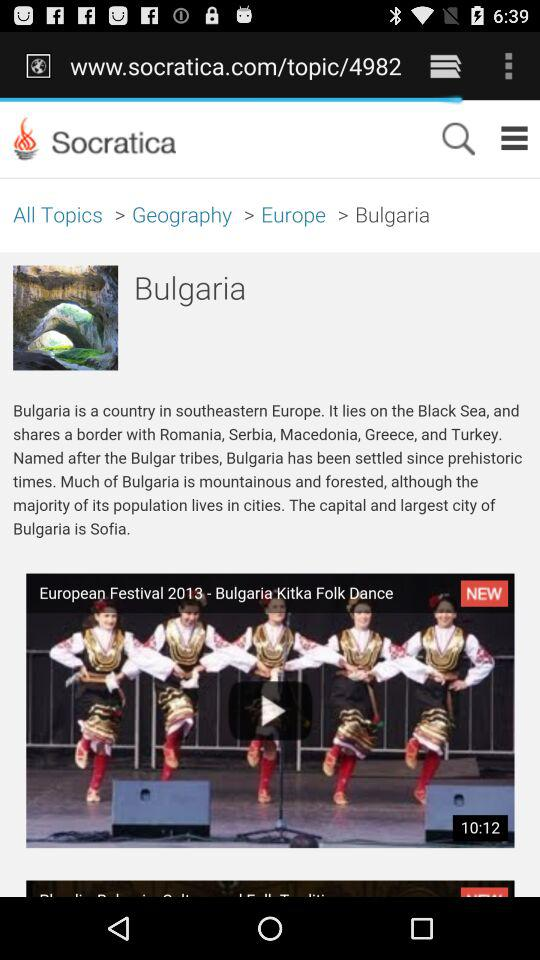At which year's European Festival is the Bulgarian Kitka Folk Dance being shown? The Bulgarian Kitka Folk Dance is being shown at the 2013 European Festival. 